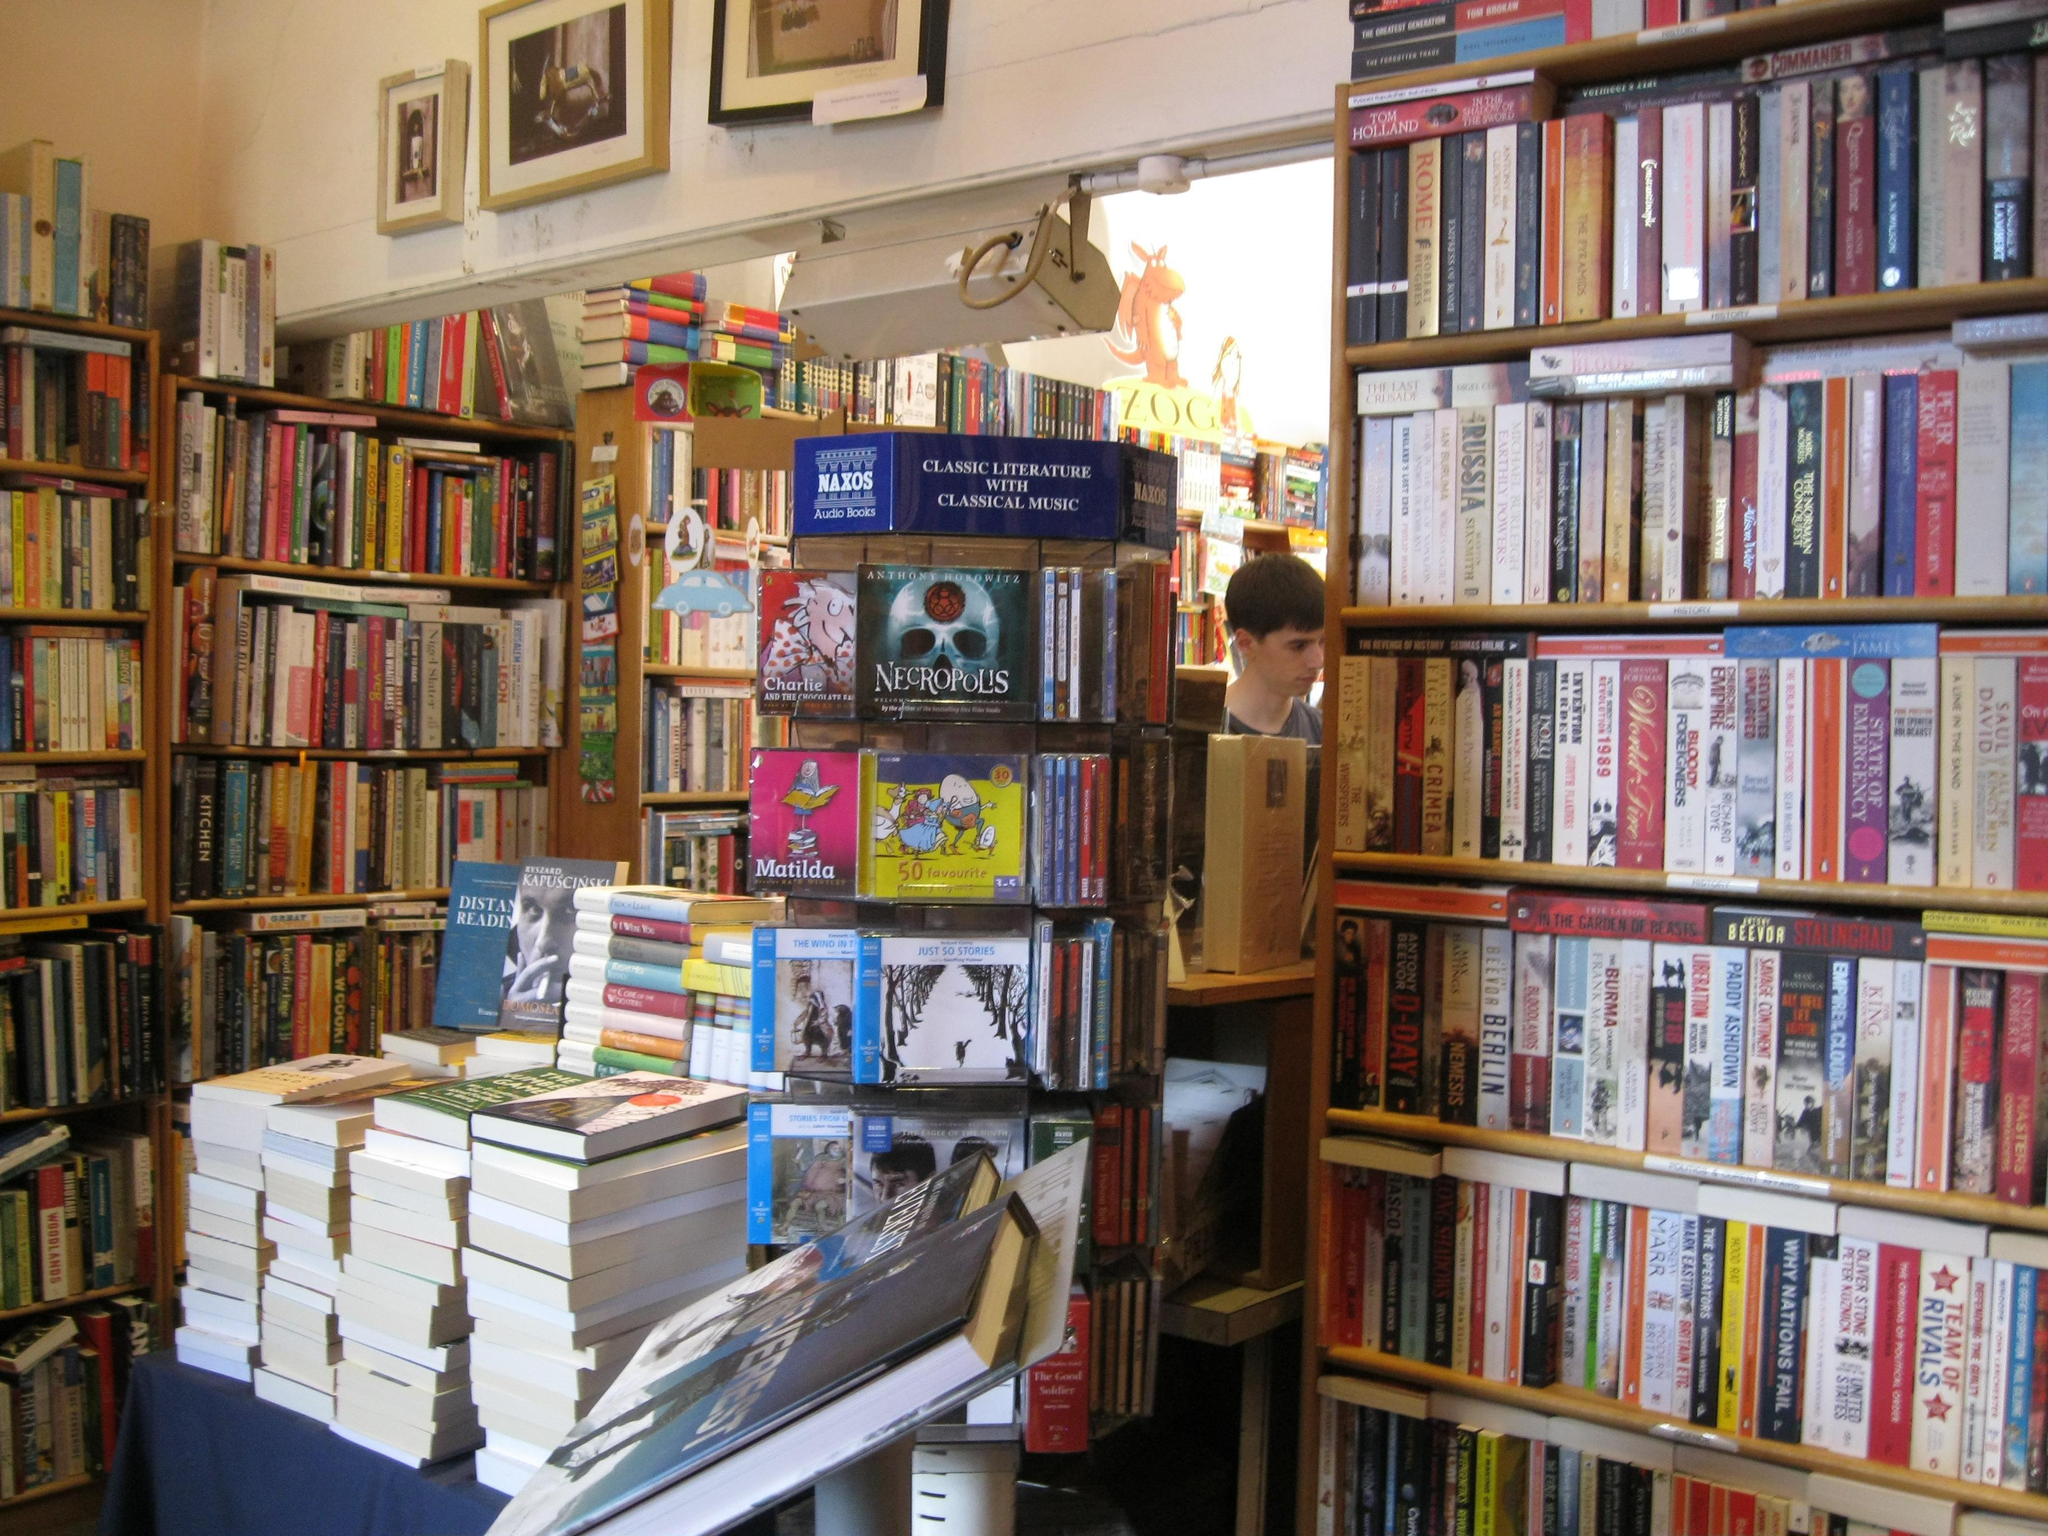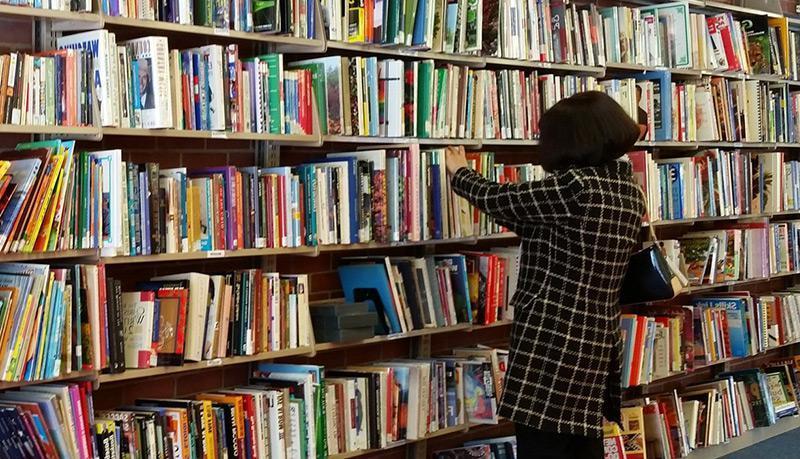The first image is the image on the left, the second image is the image on the right. Assess this claim about the two images: "The right image features one woman with a bag slung on her back, standing with her back to the camera and facing leftward toward a solid wall of books on shelves.". Correct or not? Answer yes or no. Yes. The first image is the image on the left, the second image is the image on the right. For the images displayed, is the sentence "In at least one image there is a woman with an open book in her hands standing in front of a bookshelf on the left." factually correct? Answer yes or no. No. 